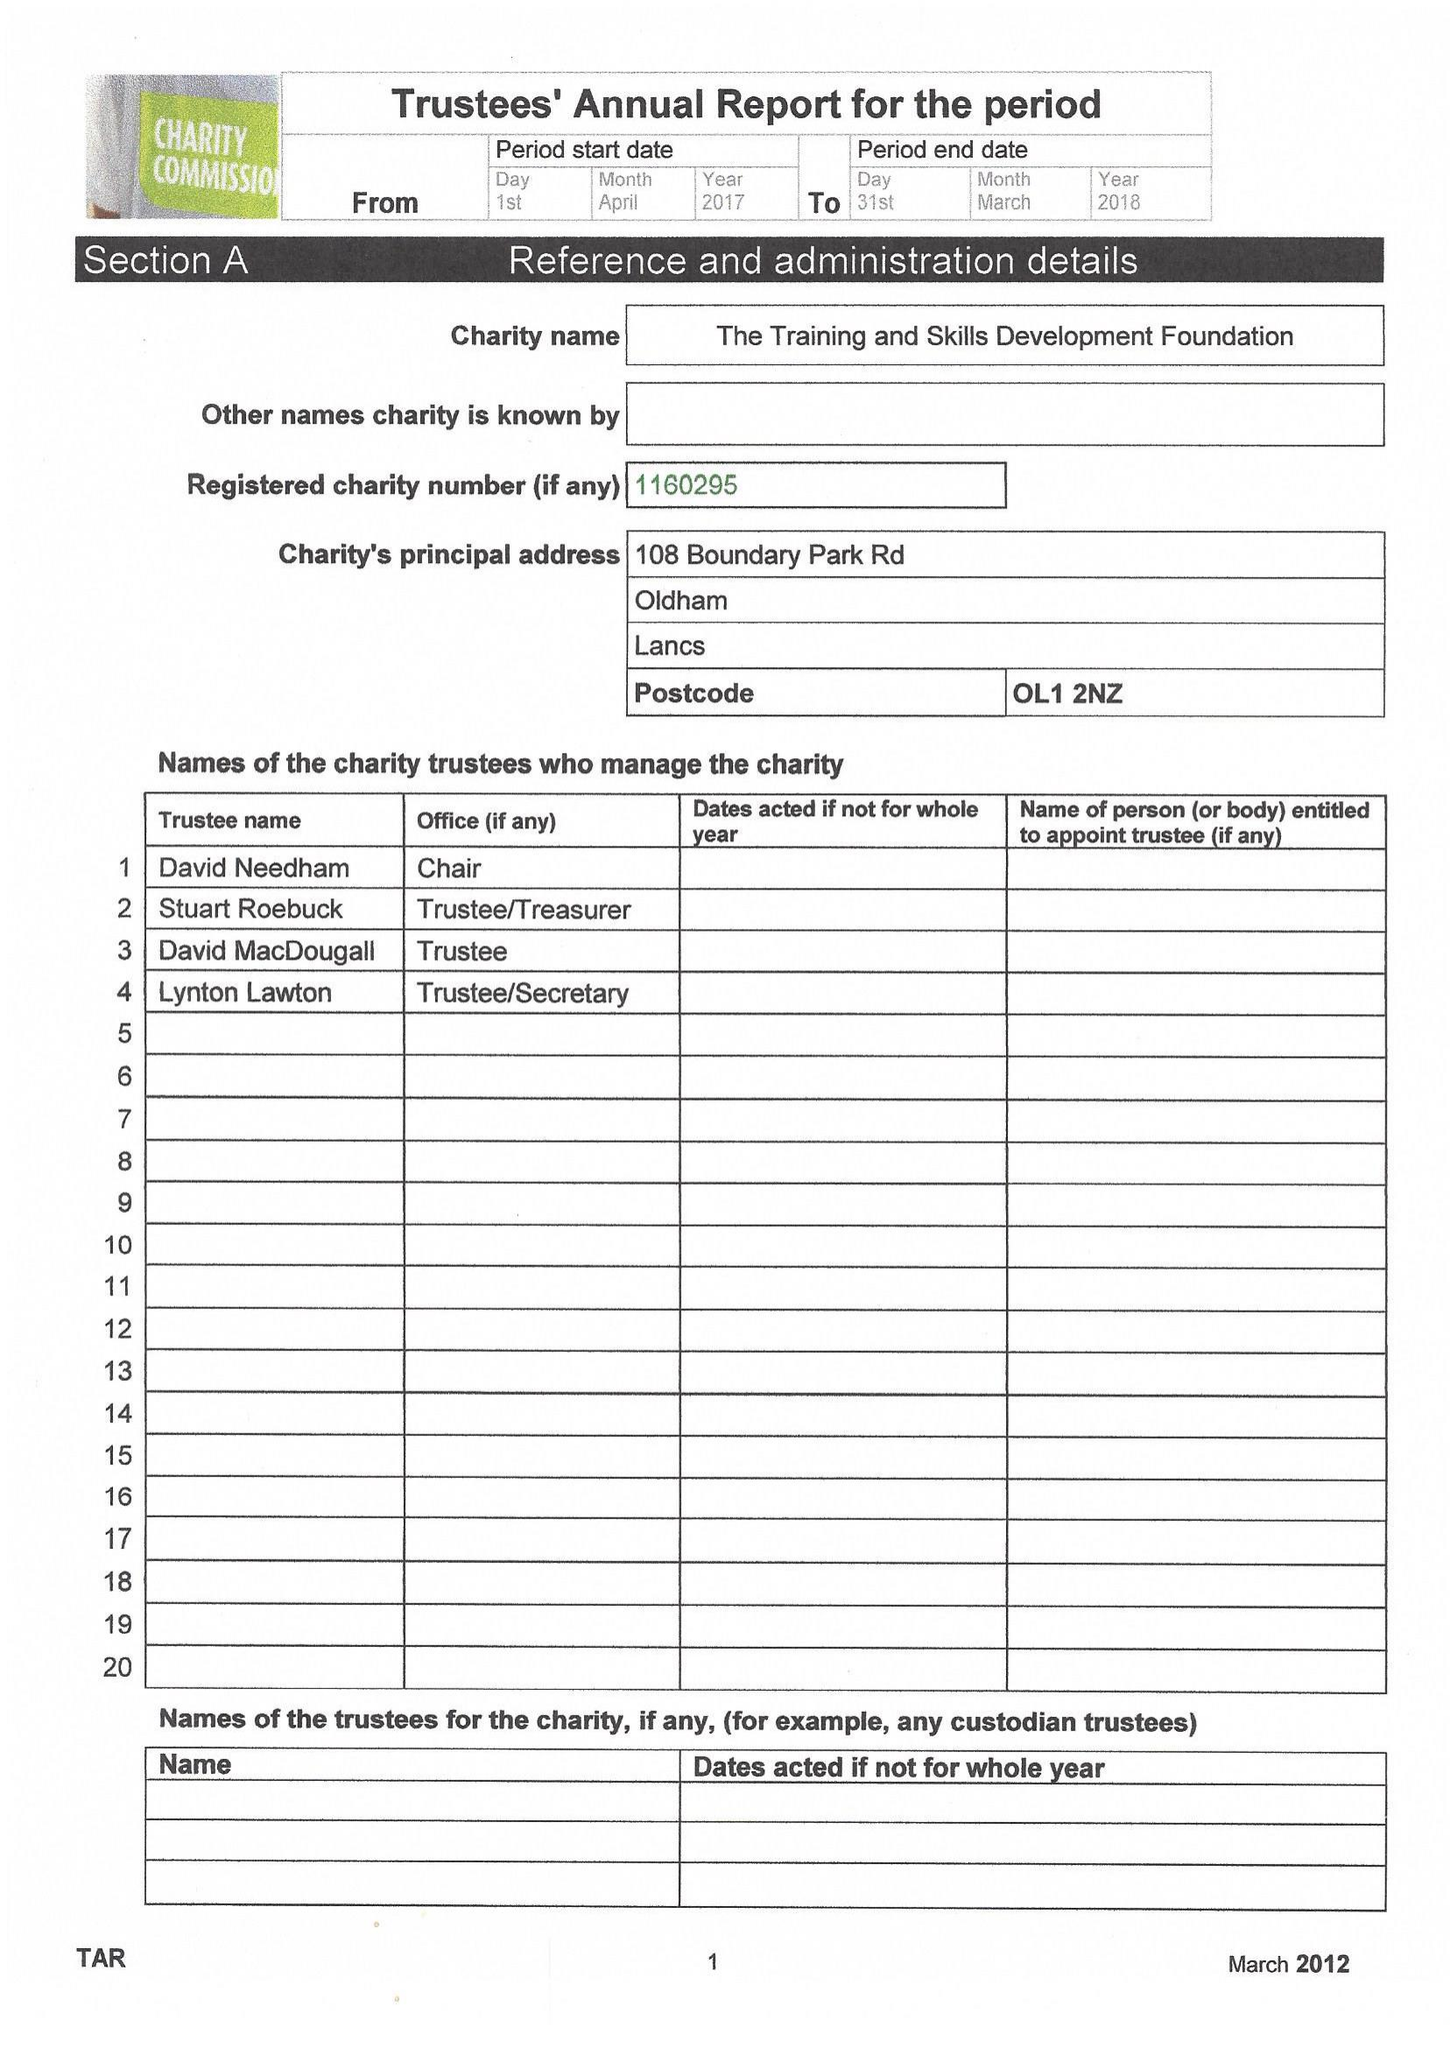What is the value for the charity_name?
Answer the question using a single word or phrase. The Training and Skills Development Foundation 